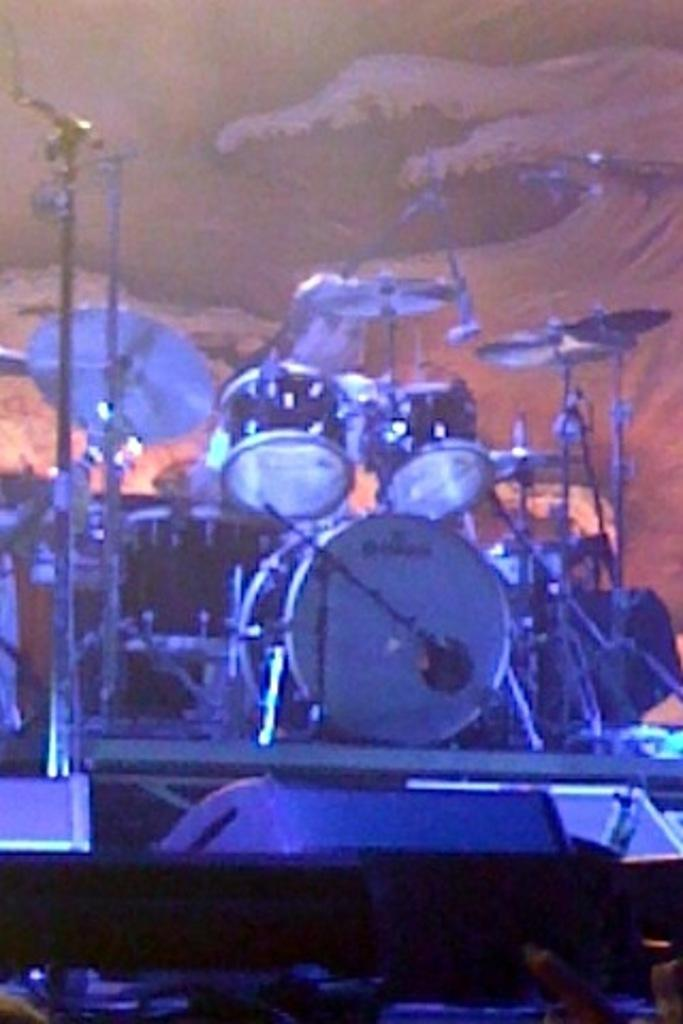What is the main subject of the image? The main subject of the image is a person sitting behind the drums. What else can be seen in the image? There are many drugs in the image. What type of humor can be seen in the image? There is no humor present in the image; it features a person sitting behind the drums and drugs. Can you tell me how many icicles are hanging from the person's elbow in the image? There are no icicles present in the image, and the person's elbow is not visible. 